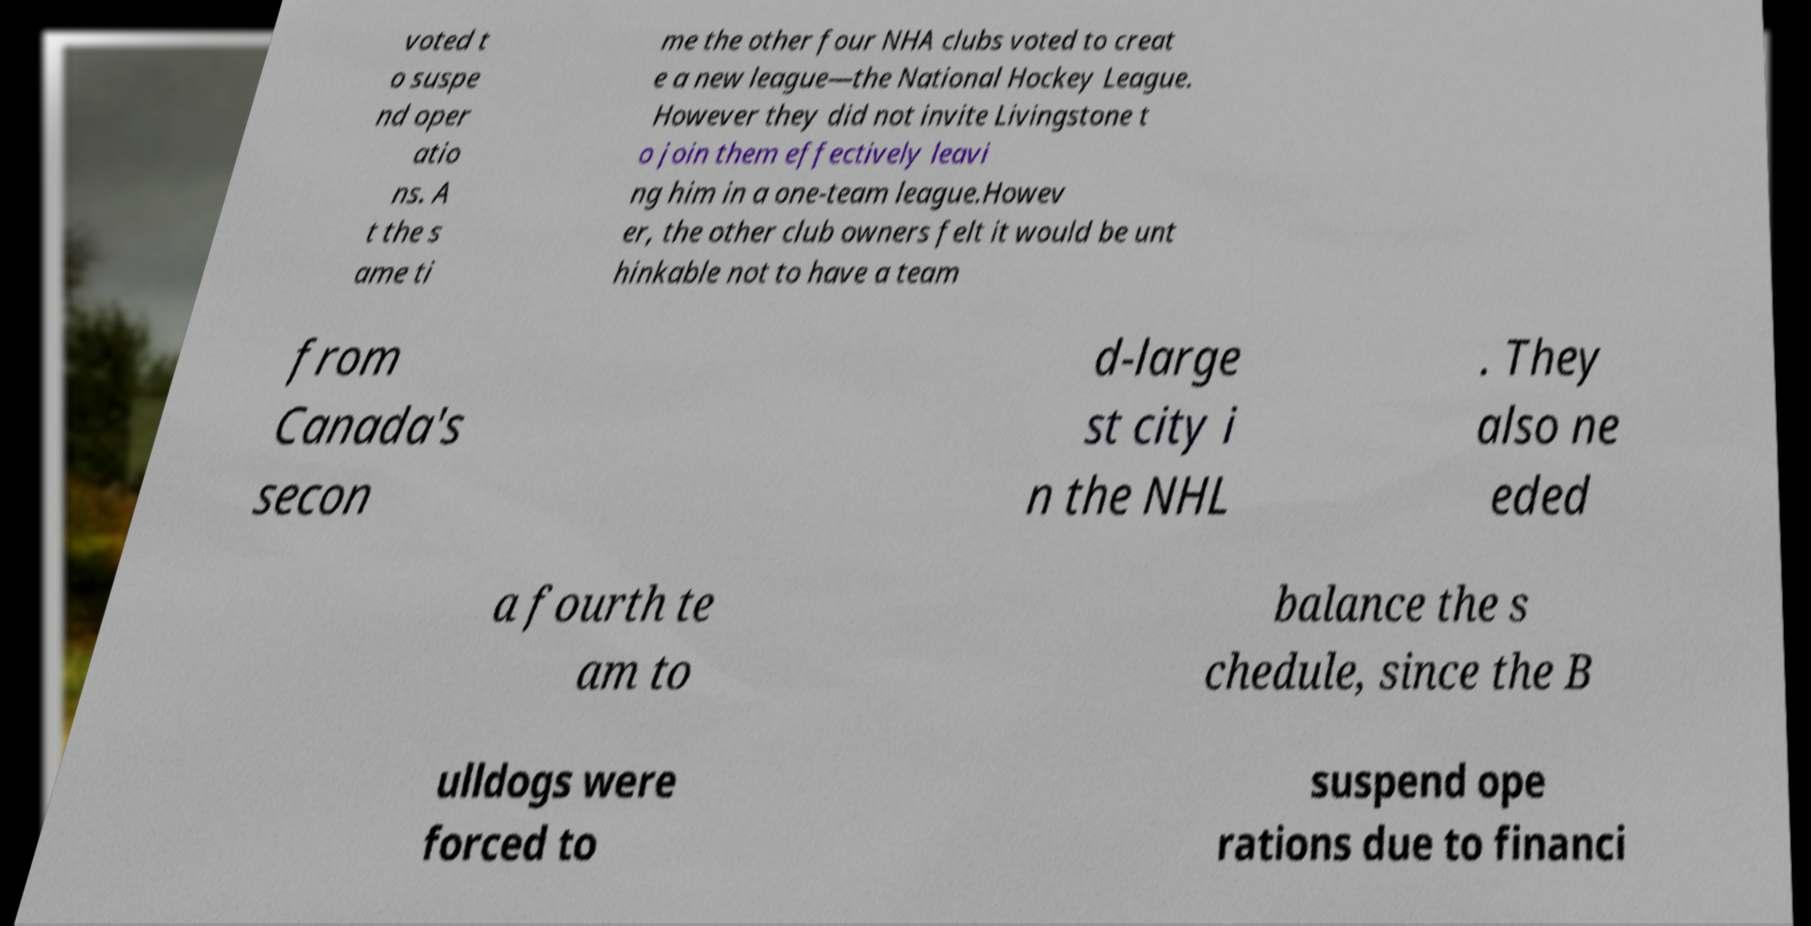Please identify and transcribe the text found in this image. voted t o suspe nd oper atio ns. A t the s ame ti me the other four NHA clubs voted to creat e a new league—the National Hockey League. However they did not invite Livingstone t o join them effectively leavi ng him in a one-team league.Howev er, the other club owners felt it would be unt hinkable not to have a team from Canada's secon d-large st city i n the NHL . They also ne eded a fourth te am to balance the s chedule, since the B ulldogs were forced to suspend ope rations due to financi 